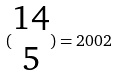Convert formula to latex. <formula><loc_0><loc_0><loc_500><loc_500>( \begin{matrix} 1 4 \\ 5 \end{matrix} ) = 2 0 0 2</formula> 